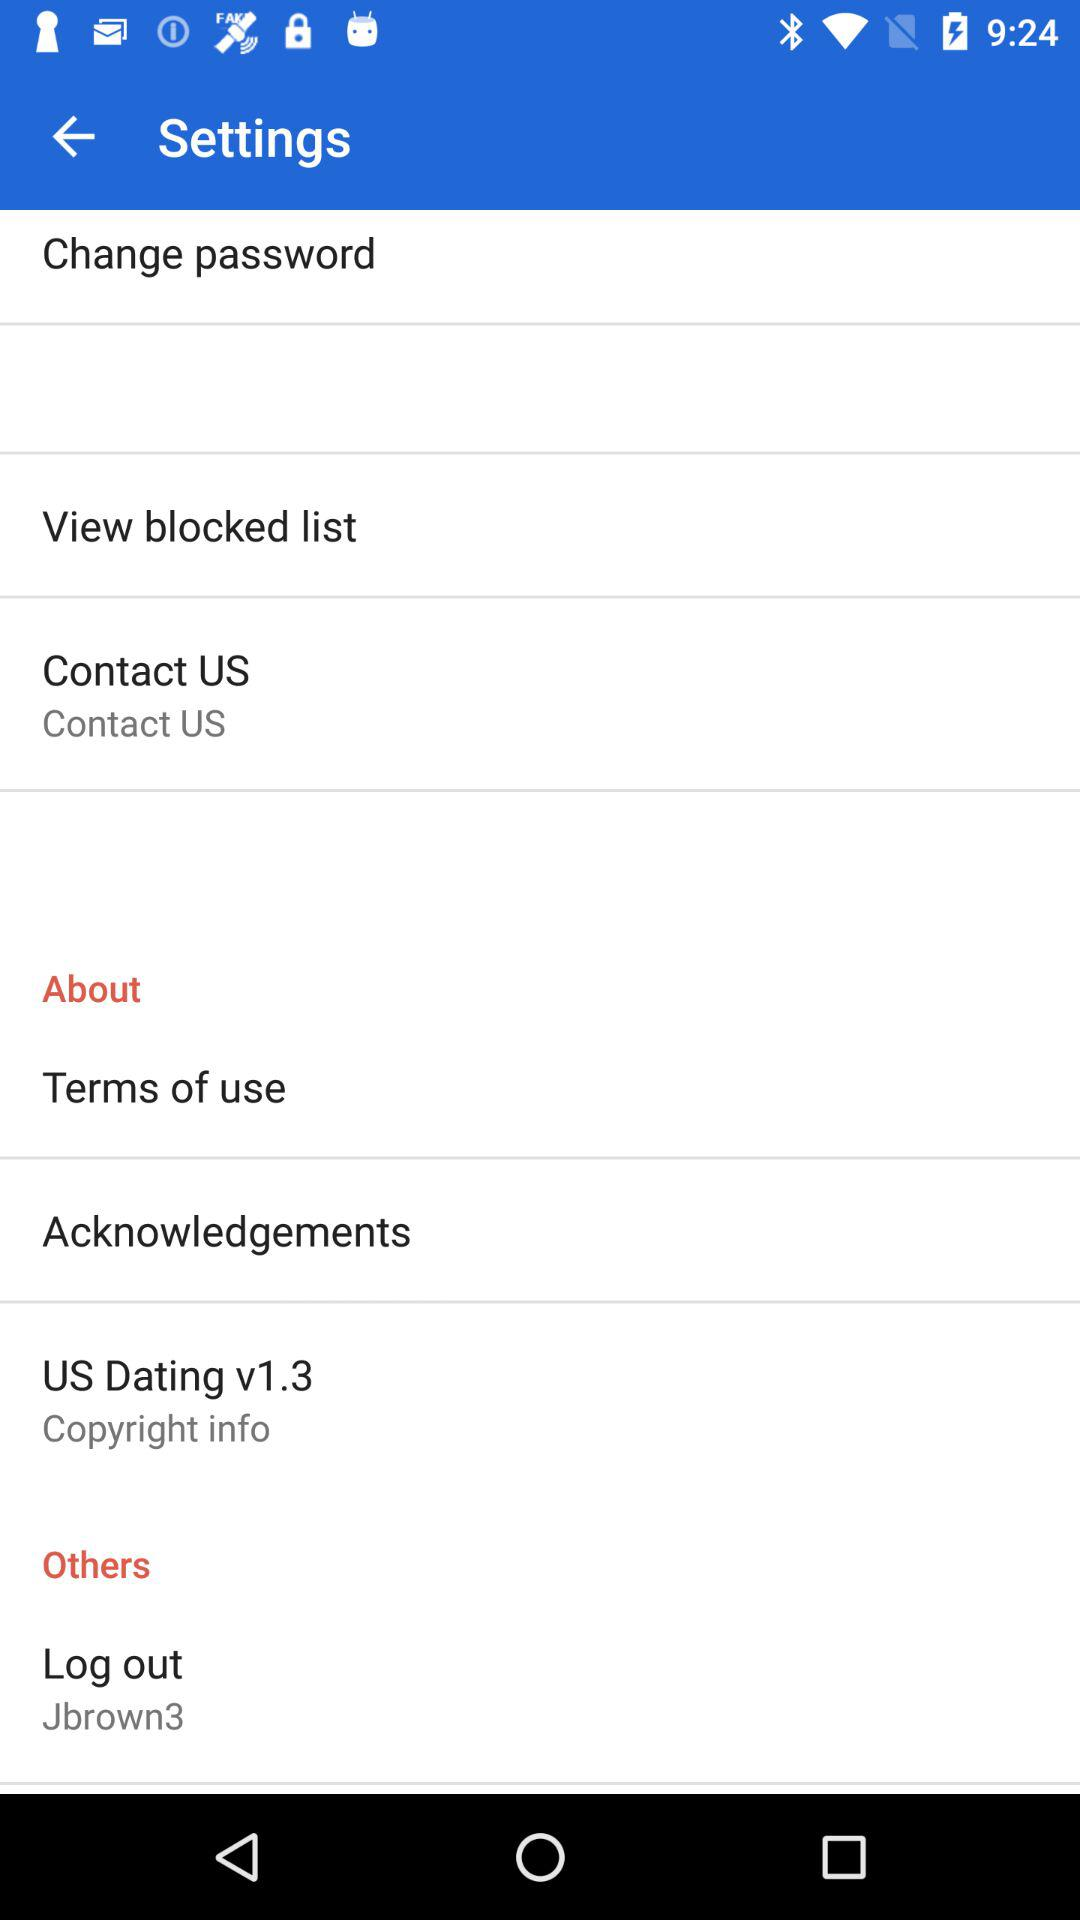What is the given username? The given username is "Jbrown3". 